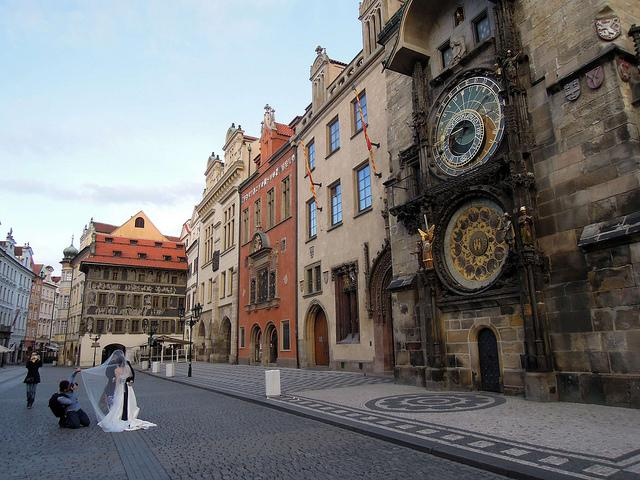What is the woman wearing? Please explain your reasoning. wedding dress. It's a long white gown with a veil 